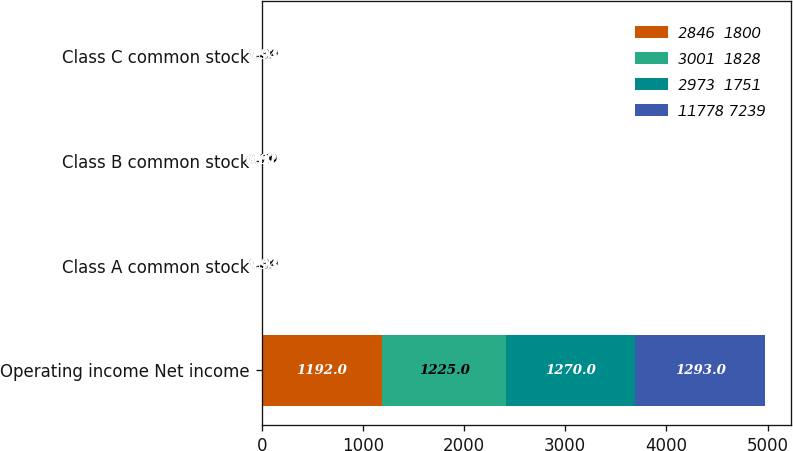Convert chart to OTSL. <chart><loc_0><loc_0><loc_500><loc_500><stacked_bar_chart><ecel><fcel>Operating income Net income<fcel>Class A common stock<fcel>Class B common stock<fcel>Class C common stock<nl><fcel>2846  1800<fcel>1192<fcel>1.86<fcel>0.78<fcel>1.86<nl><fcel>3001  1828<fcel>1225<fcel>1.89<fcel>0.79<fcel>1.89<nl><fcel>2973  1751<fcel>1270<fcel>1.93<fcel>0.81<fcel>1.93<nl><fcel>11778 7239<fcel>1293<fcel>1.94<fcel>0.82<fcel>1.94<nl></chart> 